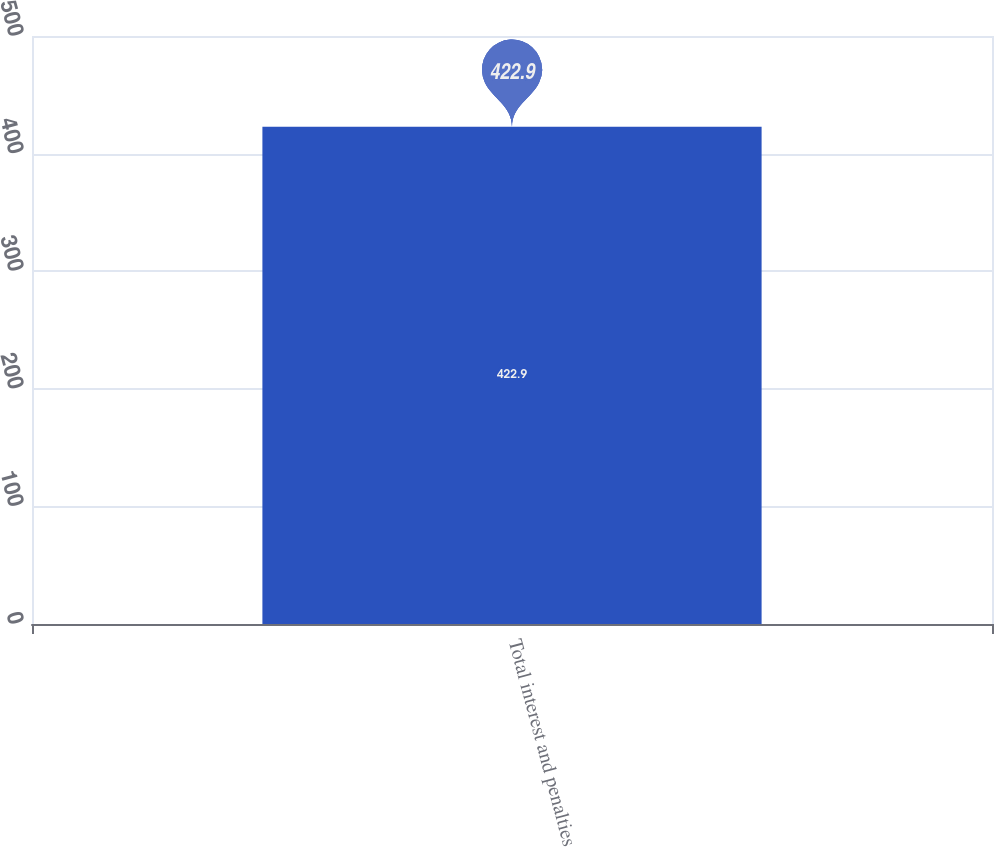Convert chart. <chart><loc_0><loc_0><loc_500><loc_500><bar_chart><fcel>Total interest and penalties<nl><fcel>422.9<nl></chart> 